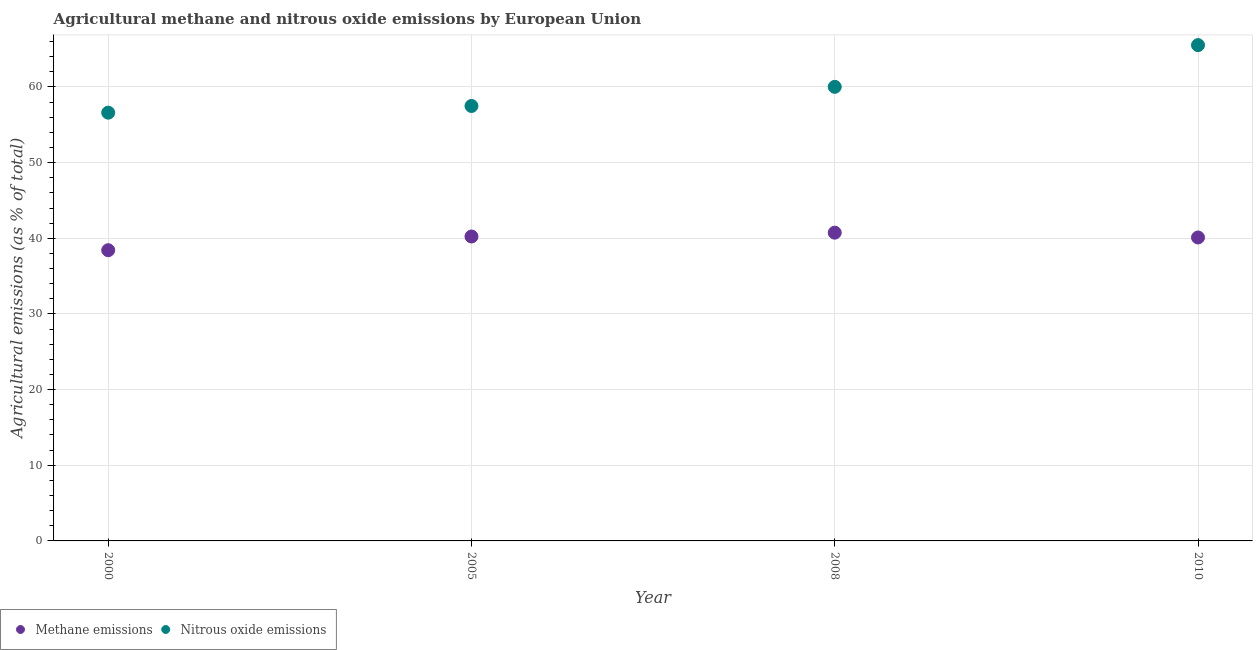How many different coloured dotlines are there?
Provide a succinct answer. 2. What is the amount of methane emissions in 2010?
Keep it short and to the point. 40.11. Across all years, what is the maximum amount of methane emissions?
Offer a terse response. 40.74. Across all years, what is the minimum amount of methane emissions?
Your response must be concise. 38.42. In which year was the amount of nitrous oxide emissions minimum?
Offer a terse response. 2000. What is the total amount of methane emissions in the graph?
Make the answer very short. 159.5. What is the difference between the amount of nitrous oxide emissions in 2008 and that in 2010?
Your answer should be compact. -5.51. What is the difference between the amount of nitrous oxide emissions in 2000 and the amount of methane emissions in 2005?
Make the answer very short. 16.37. What is the average amount of nitrous oxide emissions per year?
Offer a very short reply. 59.91. In the year 2005, what is the difference between the amount of nitrous oxide emissions and amount of methane emissions?
Your answer should be compact. 17.25. In how many years, is the amount of methane emissions greater than 8 %?
Provide a short and direct response. 4. What is the ratio of the amount of methane emissions in 2008 to that in 2010?
Ensure brevity in your answer.  1.02. What is the difference between the highest and the second highest amount of nitrous oxide emissions?
Provide a short and direct response. 5.51. What is the difference between the highest and the lowest amount of nitrous oxide emissions?
Provide a short and direct response. 8.93. Does the amount of methane emissions monotonically increase over the years?
Your answer should be compact. No. How many years are there in the graph?
Your response must be concise. 4. Where does the legend appear in the graph?
Offer a terse response. Bottom left. How many legend labels are there?
Your answer should be compact. 2. How are the legend labels stacked?
Ensure brevity in your answer.  Horizontal. What is the title of the graph?
Give a very brief answer. Agricultural methane and nitrous oxide emissions by European Union. What is the label or title of the X-axis?
Give a very brief answer. Year. What is the label or title of the Y-axis?
Offer a terse response. Agricultural emissions (as % of total). What is the Agricultural emissions (as % of total) of Methane emissions in 2000?
Give a very brief answer. 38.42. What is the Agricultural emissions (as % of total) of Nitrous oxide emissions in 2000?
Offer a terse response. 56.6. What is the Agricultural emissions (as % of total) of Methane emissions in 2005?
Give a very brief answer. 40.24. What is the Agricultural emissions (as % of total) in Nitrous oxide emissions in 2005?
Offer a very short reply. 57.49. What is the Agricultural emissions (as % of total) of Methane emissions in 2008?
Make the answer very short. 40.74. What is the Agricultural emissions (as % of total) in Nitrous oxide emissions in 2008?
Provide a short and direct response. 60.01. What is the Agricultural emissions (as % of total) of Methane emissions in 2010?
Provide a succinct answer. 40.11. What is the Agricultural emissions (as % of total) in Nitrous oxide emissions in 2010?
Make the answer very short. 65.53. Across all years, what is the maximum Agricultural emissions (as % of total) in Methane emissions?
Your response must be concise. 40.74. Across all years, what is the maximum Agricultural emissions (as % of total) of Nitrous oxide emissions?
Give a very brief answer. 65.53. Across all years, what is the minimum Agricultural emissions (as % of total) in Methane emissions?
Give a very brief answer. 38.42. Across all years, what is the minimum Agricultural emissions (as % of total) in Nitrous oxide emissions?
Ensure brevity in your answer.  56.6. What is the total Agricultural emissions (as % of total) of Methane emissions in the graph?
Offer a very short reply. 159.5. What is the total Agricultural emissions (as % of total) of Nitrous oxide emissions in the graph?
Give a very brief answer. 239.63. What is the difference between the Agricultural emissions (as % of total) of Methane emissions in 2000 and that in 2005?
Make the answer very short. -1.81. What is the difference between the Agricultural emissions (as % of total) of Nitrous oxide emissions in 2000 and that in 2005?
Provide a succinct answer. -0.89. What is the difference between the Agricultural emissions (as % of total) of Methane emissions in 2000 and that in 2008?
Provide a short and direct response. -2.32. What is the difference between the Agricultural emissions (as % of total) in Nitrous oxide emissions in 2000 and that in 2008?
Offer a terse response. -3.41. What is the difference between the Agricultural emissions (as % of total) in Methane emissions in 2000 and that in 2010?
Offer a terse response. -1.68. What is the difference between the Agricultural emissions (as % of total) in Nitrous oxide emissions in 2000 and that in 2010?
Offer a very short reply. -8.93. What is the difference between the Agricultural emissions (as % of total) of Methane emissions in 2005 and that in 2008?
Offer a terse response. -0.51. What is the difference between the Agricultural emissions (as % of total) of Nitrous oxide emissions in 2005 and that in 2008?
Ensure brevity in your answer.  -2.53. What is the difference between the Agricultural emissions (as % of total) in Methane emissions in 2005 and that in 2010?
Your answer should be compact. 0.13. What is the difference between the Agricultural emissions (as % of total) of Nitrous oxide emissions in 2005 and that in 2010?
Offer a very short reply. -8.04. What is the difference between the Agricultural emissions (as % of total) in Methane emissions in 2008 and that in 2010?
Ensure brevity in your answer.  0.64. What is the difference between the Agricultural emissions (as % of total) in Nitrous oxide emissions in 2008 and that in 2010?
Your answer should be compact. -5.51. What is the difference between the Agricultural emissions (as % of total) of Methane emissions in 2000 and the Agricultural emissions (as % of total) of Nitrous oxide emissions in 2005?
Make the answer very short. -19.06. What is the difference between the Agricultural emissions (as % of total) of Methane emissions in 2000 and the Agricultural emissions (as % of total) of Nitrous oxide emissions in 2008?
Ensure brevity in your answer.  -21.59. What is the difference between the Agricultural emissions (as % of total) in Methane emissions in 2000 and the Agricultural emissions (as % of total) in Nitrous oxide emissions in 2010?
Offer a terse response. -27.11. What is the difference between the Agricultural emissions (as % of total) of Methane emissions in 2005 and the Agricultural emissions (as % of total) of Nitrous oxide emissions in 2008?
Your answer should be very brief. -19.78. What is the difference between the Agricultural emissions (as % of total) in Methane emissions in 2005 and the Agricultural emissions (as % of total) in Nitrous oxide emissions in 2010?
Make the answer very short. -25.29. What is the difference between the Agricultural emissions (as % of total) in Methane emissions in 2008 and the Agricultural emissions (as % of total) in Nitrous oxide emissions in 2010?
Provide a succinct answer. -24.79. What is the average Agricultural emissions (as % of total) of Methane emissions per year?
Make the answer very short. 39.88. What is the average Agricultural emissions (as % of total) of Nitrous oxide emissions per year?
Make the answer very short. 59.91. In the year 2000, what is the difference between the Agricultural emissions (as % of total) of Methane emissions and Agricultural emissions (as % of total) of Nitrous oxide emissions?
Provide a short and direct response. -18.18. In the year 2005, what is the difference between the Agricultural emissions (as % of total) of Methane emissions and Agricultural emissions (as % of total) of Nitrous oxide emissions?
Make the answer very short. -17.25. In the year 2008, what is the difference between the Agricultural emissions (as % of total) in Methane emissions and Agricultural emissions (as % of total) in Nitrous oxide emissions?
Your response must be concise. -19.27. In the year 2010, what is the difference between the Agricultural emissions (as % of total) of Methane emissions and Agricultural emissions (as % of total) of Nitrous oxide emissions?
Provide a short and direct response. -25.42. What is the ratio of the Agricultural emissions (as % of total) in Methane emissions in 2000 to that in 2005?
Give a very brief answer. 0.95. What is the ratio of the Agricultural emissions (as % of total) of Nitrous oxide emissions in 2000 to that in 2005?
Give a very brief answer. 0.98. What is the ratio of the Agricultural emissions (as % of total) in Methane emissions in 2000 to that in 2008?
Your answer should be compact. 0.94. What is the ratio of the Agricultural emissions (as % of total) in Nitrous oxide emissions in 2000 to that in 2008?
Your response must be concise. 0.94. What is the ratio of the Agricultural emissions (as % of total) of Methane emissions in 2000 to that in 2010?
Make the answer very short. 0.96. What is the ratio of the Agricultural emissions (as % of total) of Nitrous oxide emissions in 2000 to that in 2010?
Provide a short and direct response. 0.86. What is the ratio of the Agricultural emissions (as % of total) in Methane emissions in 2005 to that in 2008?
Offer a very short reply. 0.99. What is the ratio of the Agricultural emissions (as % of total) in Nitrous oxide emissions in 2005 to that in 2008?
Keep it short and to the point. 0.96. What is the ratio of the Agricultural emissions (as % of total) in Methane emissions in 2005 to that in 2010?
Keep it short and to the point. 1. What is the ratio of the Agricultural emissions (as % of total) of Nitrous oxide emissions in 2005 to that in 2010?
Your response must be concise. 0.88. What is the ratio of the Agricultural emissions (as % of total) in Methane emissions in 2008 to that in 2010?
Provide a succinct answer. 1.02. What is the ratio of the Agricultural emissions (as % of total) in Nitrous oxide emissions in 2008 to that in 2010?
Offer a very short reply. 0.92. What is the difference between the highest and the second highest Agricultural emissions (as % of total) of Methane emissions?
Provide a succinct answer. 0.51. What is the difference between the highest and the second highest Agricultural emissions (as % of total) of Nitrous oxide emissions?
Keep it short and to the point. 5.51. What is the difference between the highest and the lowest Agricultural emissions (as % of total) of Methane emissions?
Provide a short and direct response. 2.32. What is the difference between the highest and the lowest Agricultural emissions (as % of total) of Nitrous oxide emissions?
Offer a very short reply. 8.93. 